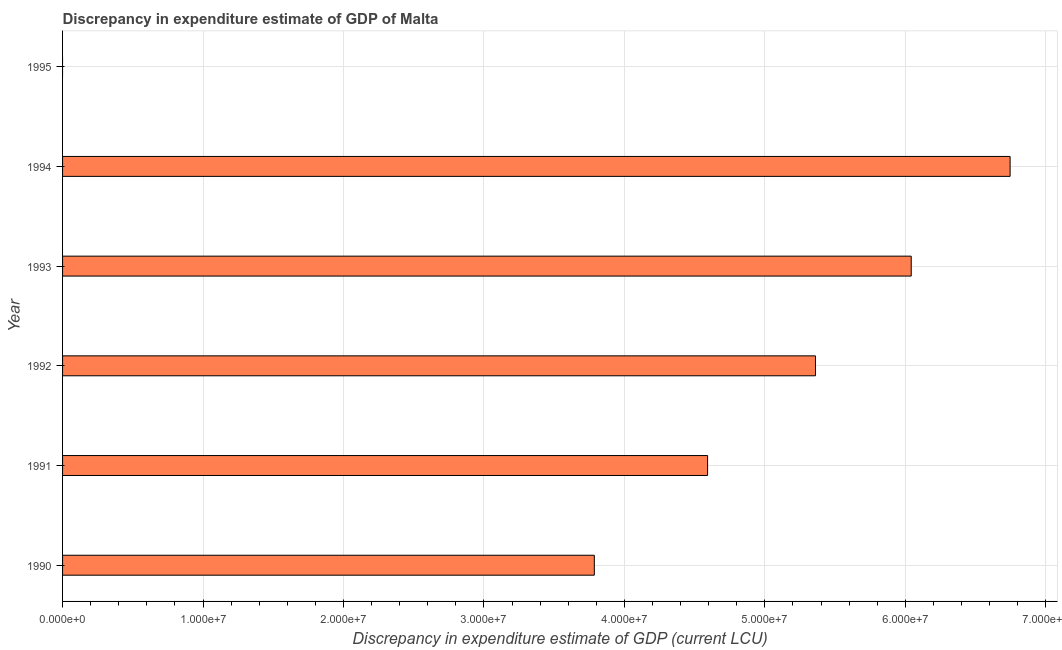Does the graph contain grids?
Provide a succinct answer. Yes. What is the title of the graph?
Provide a short and direct response. Discrepancy in expenditure estimate of GDP of Malta. What is the label or title of the X-axis?
Keep it short and to the point. Discrepancy in expenditure estimate of GDP (current LCU). What is the discrepancy in expenditure estimate of gdp in 1991?
Your answer should be very brief. 4.59e+07. Across all years, what is the maximum discrepancy in expenditure estimate of gdp?
Provide a succinct answer. 6.75e+07. Across all years, what is the minimum discrepancy in expenditure estimate of gdp?
Provide a short and direct response. 0. In which year was the discrepancy in expenditure estimate of gdp maximum?
Ensure brevity in your answer.  1994. What is the sum of the discrepancy in expenditure estimate of gdp?
Make the answer very short. 2.65e+08. What is the difference between the discrepancy in expenditure estimate of gdp in 1992 and 1993?
Offer a very short reply. -6.82e+06. What is the average discrepancy in expenditure estimate of gdp per year?
Your answer should be compact. 4.42e+07. What is the median discrepancy in expenditure estimate of gdp?
Keep it short and to the point. 4.98e+07. What is the ratio of the discrepancy in expenditure estimate of gdp in 1993 to that in 1994?
Ensure brevity in your answer.  0.9. Is the difference between the discrepancy in expenditure estimate of gdp in 1990 and 1994 greater than the difference between any two years?
Your answer should be compact. No. What is the difference between the highest and the second highest discrepancy in expenditure estimate of gdp?
Keep it short and to the point. 7.04e+06. Is the sum of the discrepancy in expenditure estimate of gdp in 1992 and 1993 greater than the maximum discrepancy in expenditure estimate of gdp across all years?
Provide a succinct answer. Yes. What is the difference between the highest and the lowest discrepancy in expenditure estimate of gdp?
Provide a succinct answer. 6.75e+07. In how many years, is the discrepancy in expenditure estimate of gdp greater than the average discrepancy in expenditure estimate of gdp taken over all years?
Your answer should be very brief. 4. How many years are there in the graph?
Provide a succinct answer. 6. What is the difference between two consecutive major ticks on the X-axis?
Your answer should be compact. 1.00e+07. What is the Discrepancy in expenditure estimate of GDP (current LCU) of 1990?
Ensure brevity in your answer.  3.79e+07. What is the Discrepancy in expenditure estimate of GDP (current LCU) of 1991?
Give a very brief answer. 4.59e+07. What is the Discrepancy in expenditure estimate of GDP (current LCU) of 1992?
Your answer should be compact. 5.36e+07. What is the Discrepancy in expenditure estimate of GDP (current LCU) in 1993?
Offer a terse response. 6.04e+07. What is the Discrepancy in expenditure estimate of GDP (current LCU) in 1994?
Make the answer very short. 6.75e+07. What is the Discrepancy in expenditure estimate of GDP (current LCU) of 1995?
Ensure brevity in your answer.  0. What is the difference between the Discrepancy in expenditure estimate of GDP (current LCU) in 1990 and 1991?
Your answer should be very brief. -8.06e+06. What is the difference between the Discrepancy in expenditure estimate of GDP (current LCU) in 1990 and 1992?
Your answer should be very brief. -1.57e+07. What is the difference between the Discrepancy in expenditure estimate of GDP (current LCU) in 1990 and 1993?
Offer a very short reply. -2.26e+07. What is the difference between the Discrepancy in expenditure estimate of GDP (current LCU) in 1990 and 1994?
Keep it short and to the point. -2.96e+07. What is the difference between the Discrepancy in expenditure estimate of GDP (current LCU) in 1991 and 1992?
Your answer should be compact. -7.68e+06. What is the difference between the Discrepancy in expenditure estimate of GDP (current LCU) in 1991 and 1993?
Give a very brief answer. -1.45e+07. What is the difference between the Discrepancy in expenditure estimate of GDP (current LCU) in 1991 and 1994?
Your answer should be compact. -2.15e+07. What is the difference between the Discrepancy in expenditure estimate of GDP (current LCU) in 1992 and 1993?
Your response must be concise. -6.82e+06. What is the difference between the Discrepancy in expenditure estimate of GDP (current LCU) in 1992 and 1994?
Provide a succinct answer. -1.39e+07. What is the difference between the Discrepancy in expenditure estimate of GDP (current LCU) in 1993 and 1994?
Your response must be concise. -7.04e+06. What is the ratio of the Discrepancy in expenditure estimate of GDP (current LCU) in 1990 to that in 1991?
Make the answer very short. 0.82. What is the ratio of the Discrepancy in expenditure estimate of GDP (current LCU) in 1990 to that in 1992?
Offer a terse response. 0.71. What is the ratio of the Discrepancy in expenditure estimate of GDP (current LCU) in 1990 to that in 1993?
Keep it short and to the point. 0.63. What is the ratio of the Discrepancy in expenditure estimate of GDP (current LCU) in 1990 to that in 1994?
Provide a short and direct response. 0.56. What is the ratio of the Discrepancy in expenditure estimate of GDP (current LCU) in 1991 to that in 1992?
Your answer should be very brief. 0.86. What is the ratio of the Discrepancy in expenditure estimate of GDP (current LCU) in 1991 to that in 1993?
Give a very brief answer. 0.76. What is the ratio of the Discrepancy in expenditure estimate of GDP (current LCU) in 1991 to that in 1994?
Offer a terse response. 0.68. What is the ratio of the Discrepancy in expenditure estimate of GDP (current LCU) in 1992 to that in 1993?
Offer a very short reply. 0.89. What is the ratio of the Discrepancy in expenditure estimate of GDP (current LCU) in 1992 to that in 1994?
Offer a terse response. 0.8. What is the ratio of the Discrepancy in expenditure estimate of GDP (current LCU) in 1993 to that in 1994?
Your answer should be compact. 0.9. 